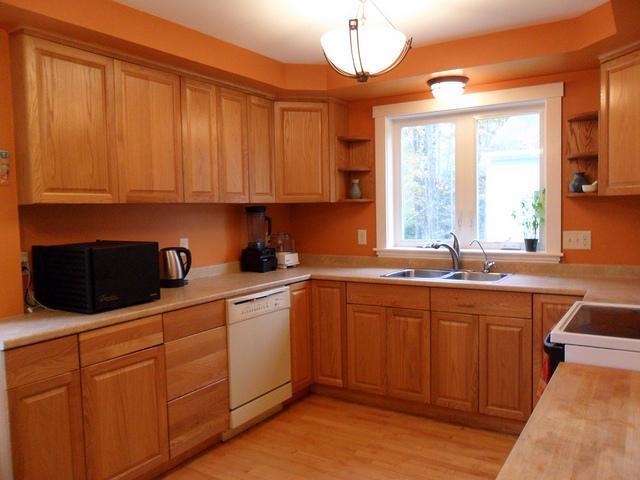How many people ride in bicycle?
Give a very brief answer. 0. 